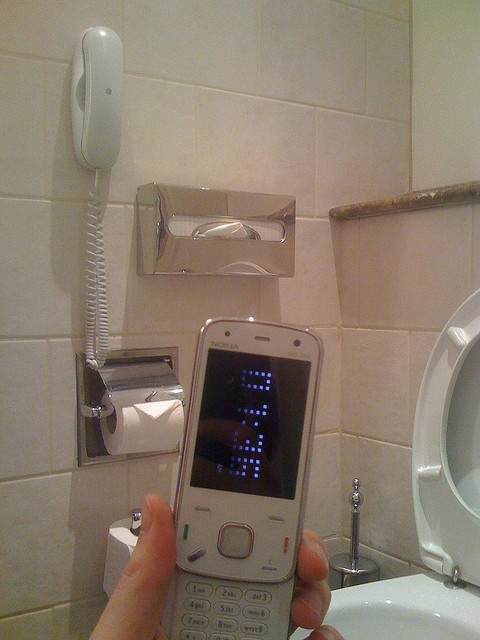Describe the objects in this image and their specific colors. I can see cell phone in olive, gray, and black tones, toilet in olive, darkgray, gray, and lightgray tones, and people in olive, brown, and maroon tones in this image. 